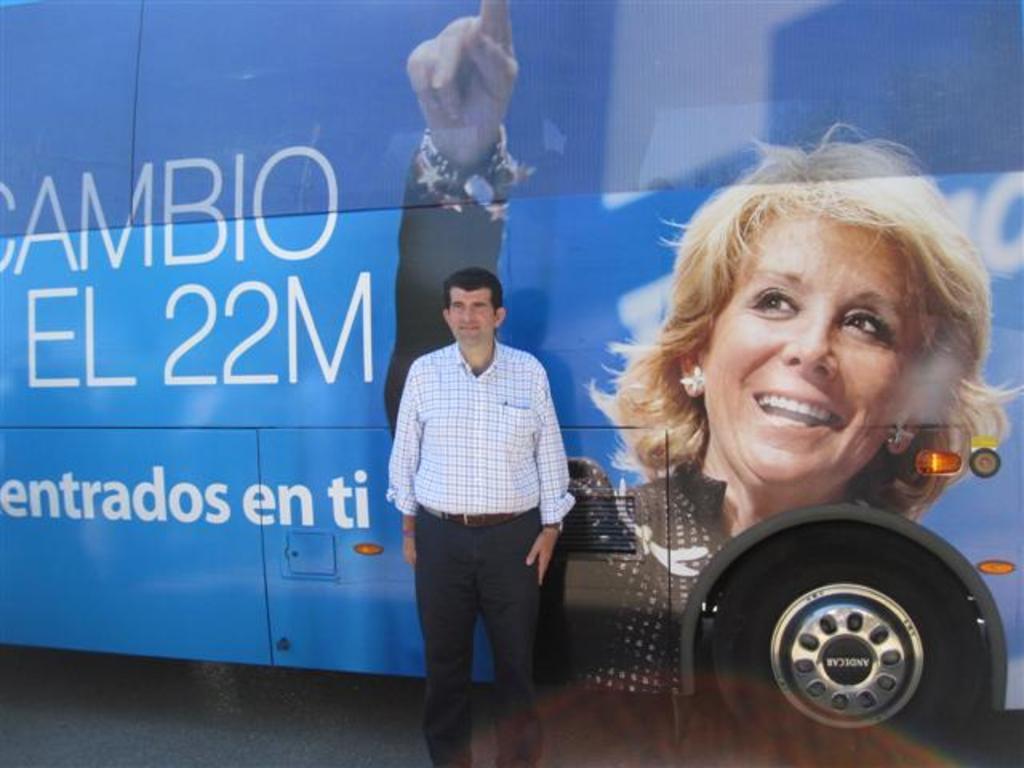Describe this image in one or two sentences. In the image we can see there is a person standing and behind him there is a bus on which there is a woman photo. The bus is in blue colour. 